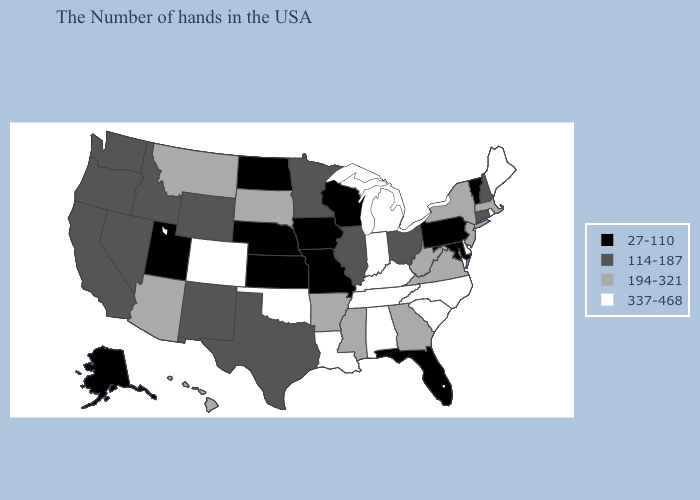What is the value of North Carolina?
Write a very short answer. 337-468. Does Nevada have a higher value than Tennessee?
Give a very brief answer. No. Does the first symbol in the legend represent the smallest category?
Keep it brief. Yes. Among the states that border Oklahoma , which have the lowest value?
Concise answer only. Missouri, Kansas. Does Missouri have the lowest value in the MidWest?
Give a very brief answer. Yes. What is the lowest value in states that border Montana?
Write a very short answer. 27-110. Does Delaware have the same value as Idaho?
Quick response, please. No. Does Maine have the highest value in the Northeast?
Answer briefly. Yes. Name the states that have a value in the range 27-110?
Keep it brief. Vermont, Maryland, Pennsylvania, Florida, Wisconsin, Missouri, Iowa, Kansas, Nebraska, North Dakota, Utah, Alaska. Is the legend a continuous bar?
Short answer required. No. What is the value of Ohio?
Write a very short answer. 114-187. Which states have the highest value in the USA?
Answer briefly. Maine, Rhode Island, Delaware, North Carolina, South Carolina, Michigan, Kentucky, Indiana, Alabama, Tennessee, Louisiana, Oklahoma, Colorado. Which states have the lowest value in the West?
Be succinct. Utah, Alaska. What is the highest value in the USA?
Quick response, please. 337-468. 